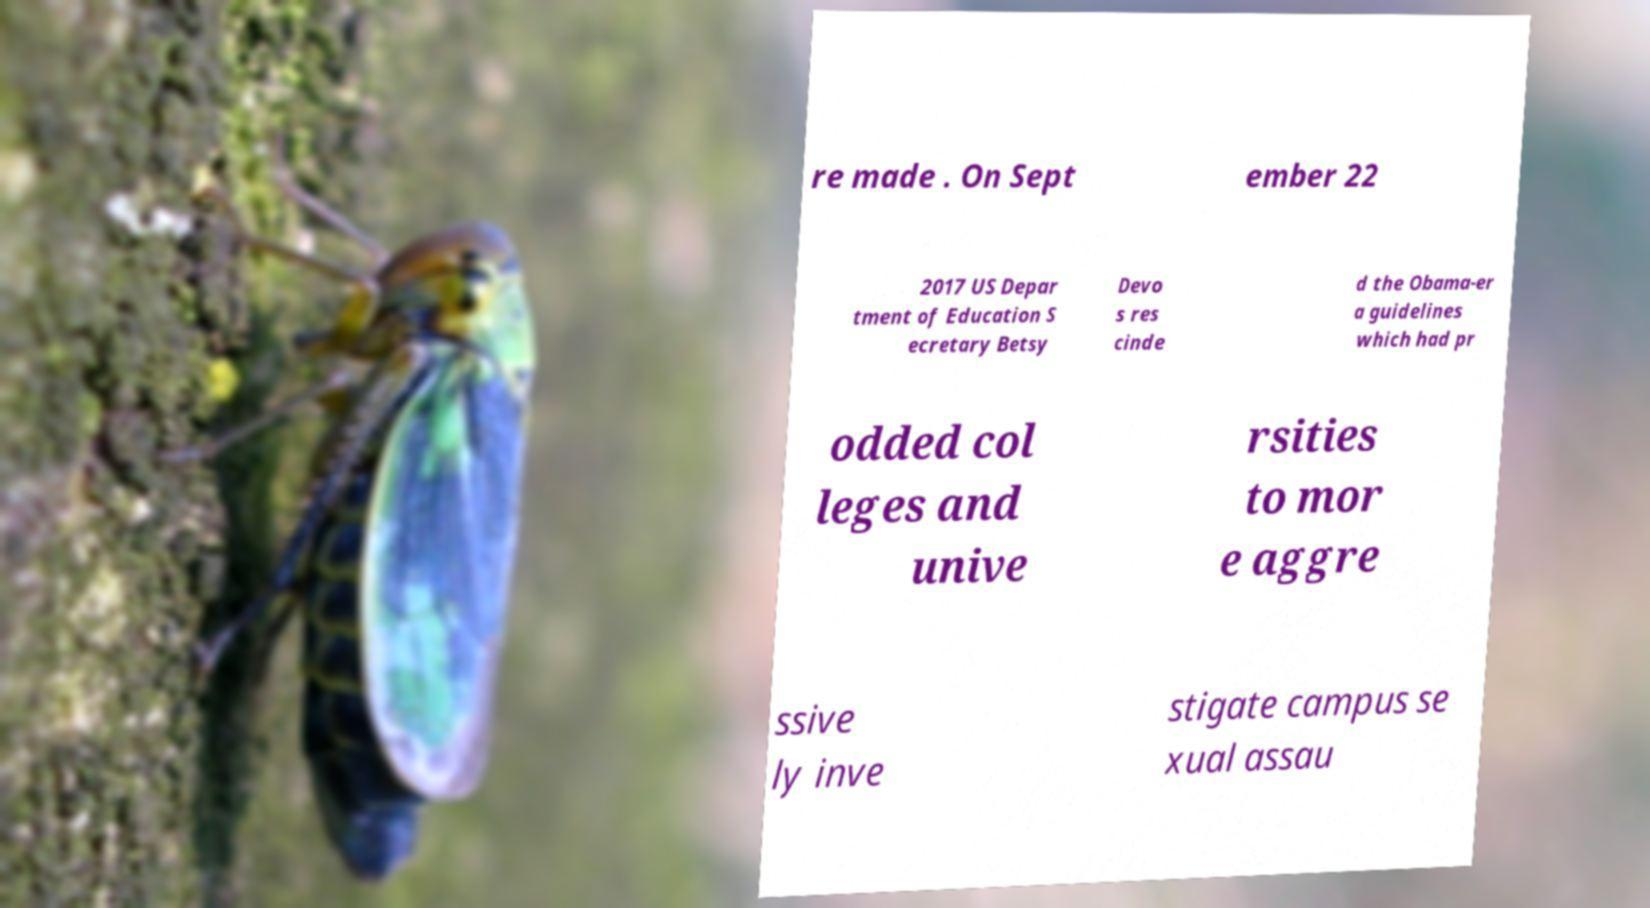I need the written content from this picture converted into text. Can you do that? re made . On Sept ember 22 2017 US Depar tment of Education S ecretary Betsy Devo s res cinde d the Obama-er a guidelines which had pr odded col leges and unive rsities to mor e aggre ssive ly inve stigate campus se xual assau 